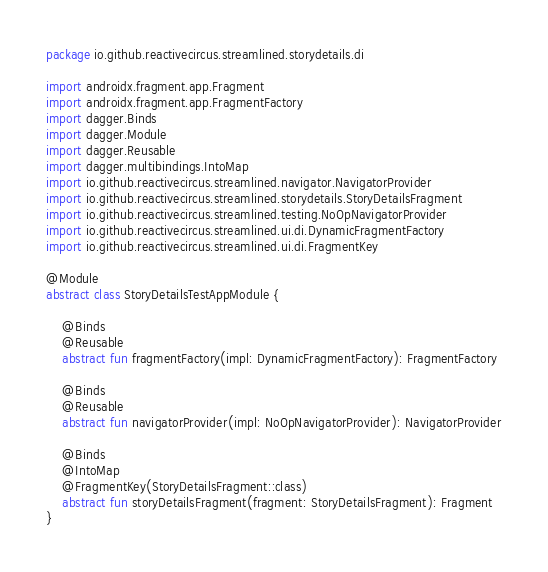Convert code to text. <code><loc_0><loc_0><loc_500><loc_500><_Kotlin_>package io.github.reactivecircus.streamlined.storydetails.di

import androidx.fragment.app.Fragment
import androidx.fragment.app.FragmentFactory
import dagger.Binds
import dagger.Module
import dagger.Reusable
import dagger.multibindings.IntoMap
import io.github.reactivecircus.streamlined.navigator.NavigatorProvider
import io.github.reactivecircus.streamlined.storydetails.StoryDetailsFragment
import io.github.reactivecircus.streamlined.testing.NoOpNavigatorProvider
import io.github.reactivecircus.streamlined.ui.di.DynamicFragmentFactory
import io.github.reactivecircus.streamlined.ui.di.FragmentKey

@Module
abstract class StoryDetailsTestAppModule {

    @Binds
    @Reusable
    abstract fun fragmentFactory(impl: DynamicFragmentFactory): FragmentFactory

    @Binds
    @Reusable
    abstract fun navigatorProvider(impl: NoOpNavigatorProvider): NavigatorProvider

    @Binds
    @IntoMap
    @FragmentKey(StoryDetailsFragment::class)
    abstract fun storyDetailsFragment(fragment: StoryDetailsFragment): Fragment
}
</code> 